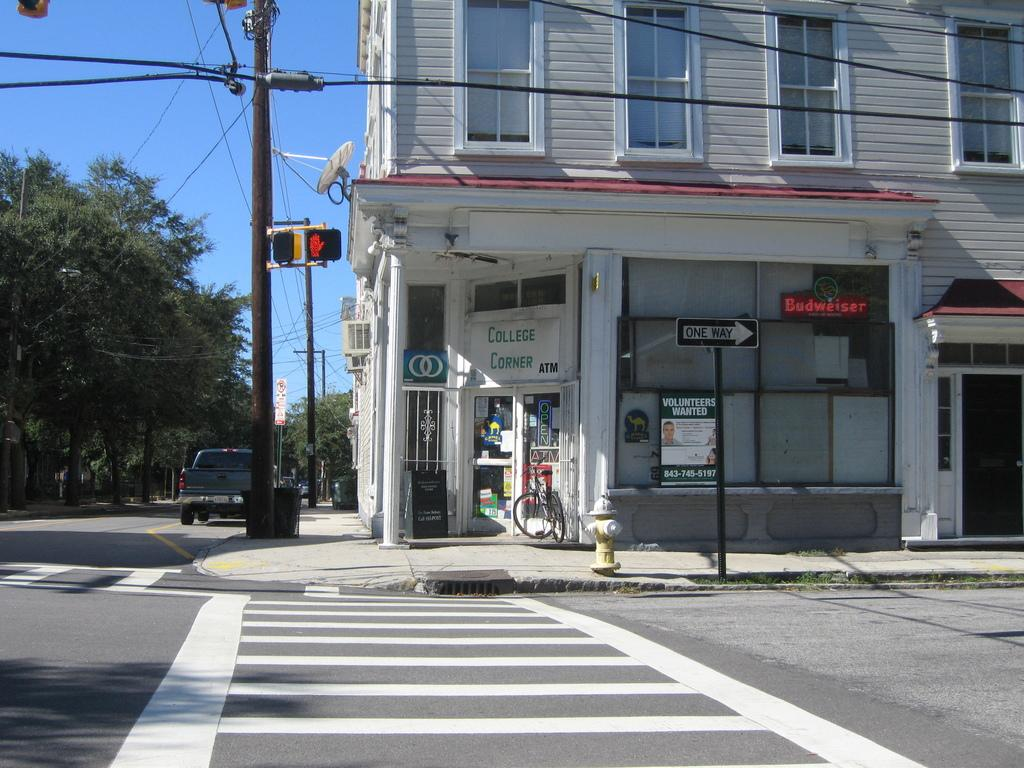<image>
Write a terse but informative summary of the picture. a one way street cornor with a store called college corner 